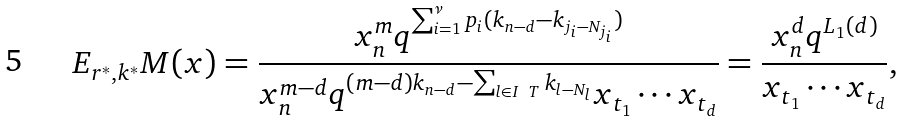Convert formula to latex. <formula><loc_0><loc_0><loc_500><loc_500>E _ { r ^ { * } , k ^ { * } } M ( x ) = \frac { x _ { n } ^ { m } q ^ { \sum _ { i = 1 } ^ { \nu } p _ { i } ( k _ { n - d } - k _ { j _ { i } - N _ { j _ { i } } } ) } } { x _ { n } ^ { m - d } q ^ { ( m - d ) k _ { n - d } - \sum _ { l \in I \ T } k _ { l - N _ { l } } } x _ { t _ { 1 } } \cdots x _ { t _ { d } } } = \frac { x _ { n } ^ { d } q ^ { L _ { 1 } ( d ) } } { x _ { t _ { 1 } } \cdots x _ { t _ { d } } } ,</formula> 